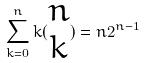Convert formula to latex. <formula><loc_0><loc_0><loc_500><loc_500>\sum _ { k = 0 } ^ { n } k ( \begin{matrix} n \\ k \end{matrix} ) = n 2 ^ { n - 1 }</formula> 